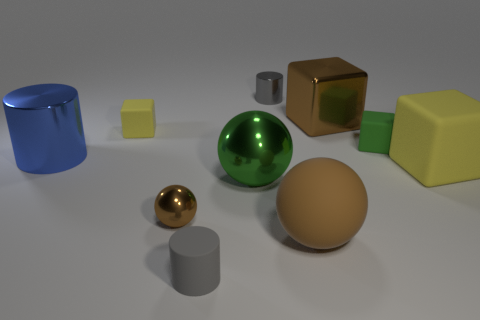Is the yellow block behind the large shiny cylinder made of the same material as the big brown object behind the large green metal thing?
Keep it short and to the point. No. There is a matte cube that is on the left side of the big rubber block and right of the tiny rubber cylinder; what size is it?
Your response must be concise. Small. What is the color of the large matte thing that is the same shape as the small green thing?
Provide a succinct answer. Yellow. There is a shiny object on the right side of the gray thing that is to the right of the gray matte thing; what is its color?
Ensure brevity in your answer.  Brown. The tiny green matte object has what shape?
Make the answer very short. Cube. There is a matte thing that is behind the big matte cube and left of the small green rubber cube; what shape is it?
Make the answer very short. Cube. There is a tiny ball that is made of the same material as the large blue cylinder; what color is it?
Your answer should be compact. Brown. There is a big brown object behind the brown thing left of the big brown thing that is in front of the shiny block; what is its shape?
Make the answer very short. Cube. What is the size of the green rubber thing?
Your answer should be compact. Small. There is another yellow object that is made of the same material as the big yellow thing; what shape is it?
Provide a short and direct response. Cube. 